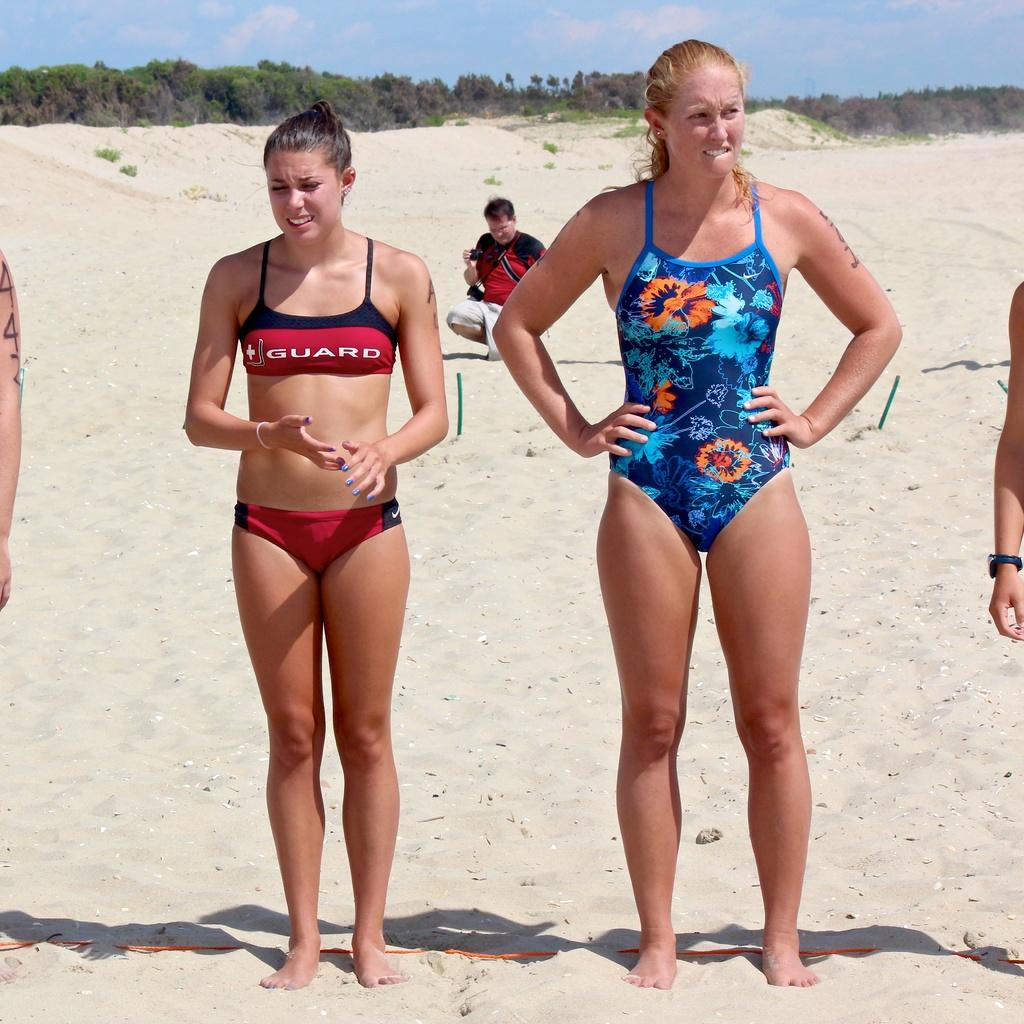What are the people in the image doing? The women are standing on the sand, and the man is sitting on the sand. What is the man holding in his hands? The man is holding a camera in his hands. What is the condition of the sky in the image? Clouds are present in the sky. What type of seat is the man using to sit on the sand? There is no seat visible in the image; the man is sitting directly on the sand. Can you tell me how many sea creatures are swimming in the image? There is no sea or sea creatures present in the image; it features people on sand with a background of trees and sky. 